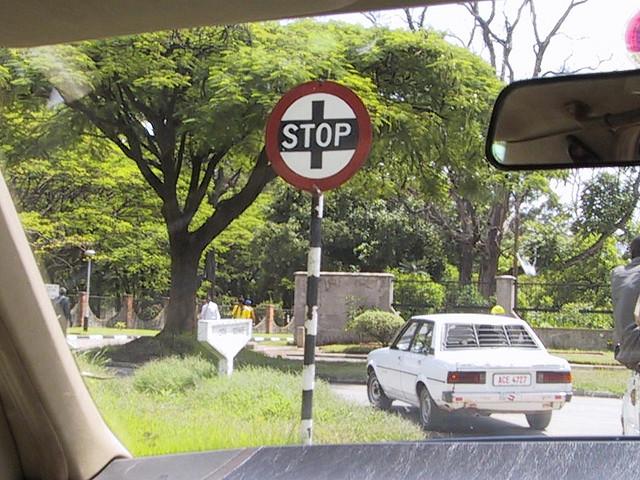Is this a standard stop sign in the U.S.?
Quick response, please. No. Where is the rear-view mirror?
Short answer required. Top right. How many brake lights does the car have?
Be succinct. 2. Who is following this person?
Give a very brief answer. Car. 